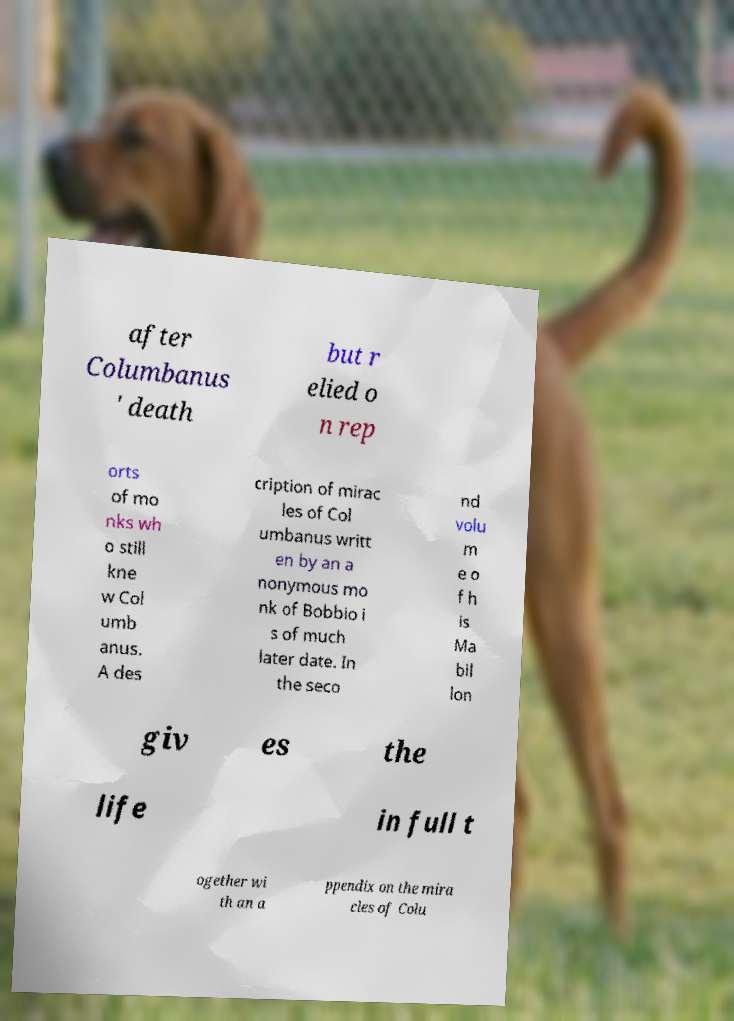What messages or text are displayed in this image? I need them in a readable, typed format. after Columbanus ' death but r elied o n rep orts of mo nks wh o still kne w Col umb anus. A des cription of mirac les of Col umbanus writt en by an a nonymous mo nk of Bobbio i s of much later date. In the seco nd volu m e o f h is Ma bil lon giv es the life in full t ogether wi th an a ppendix on the mira cles of Colu 